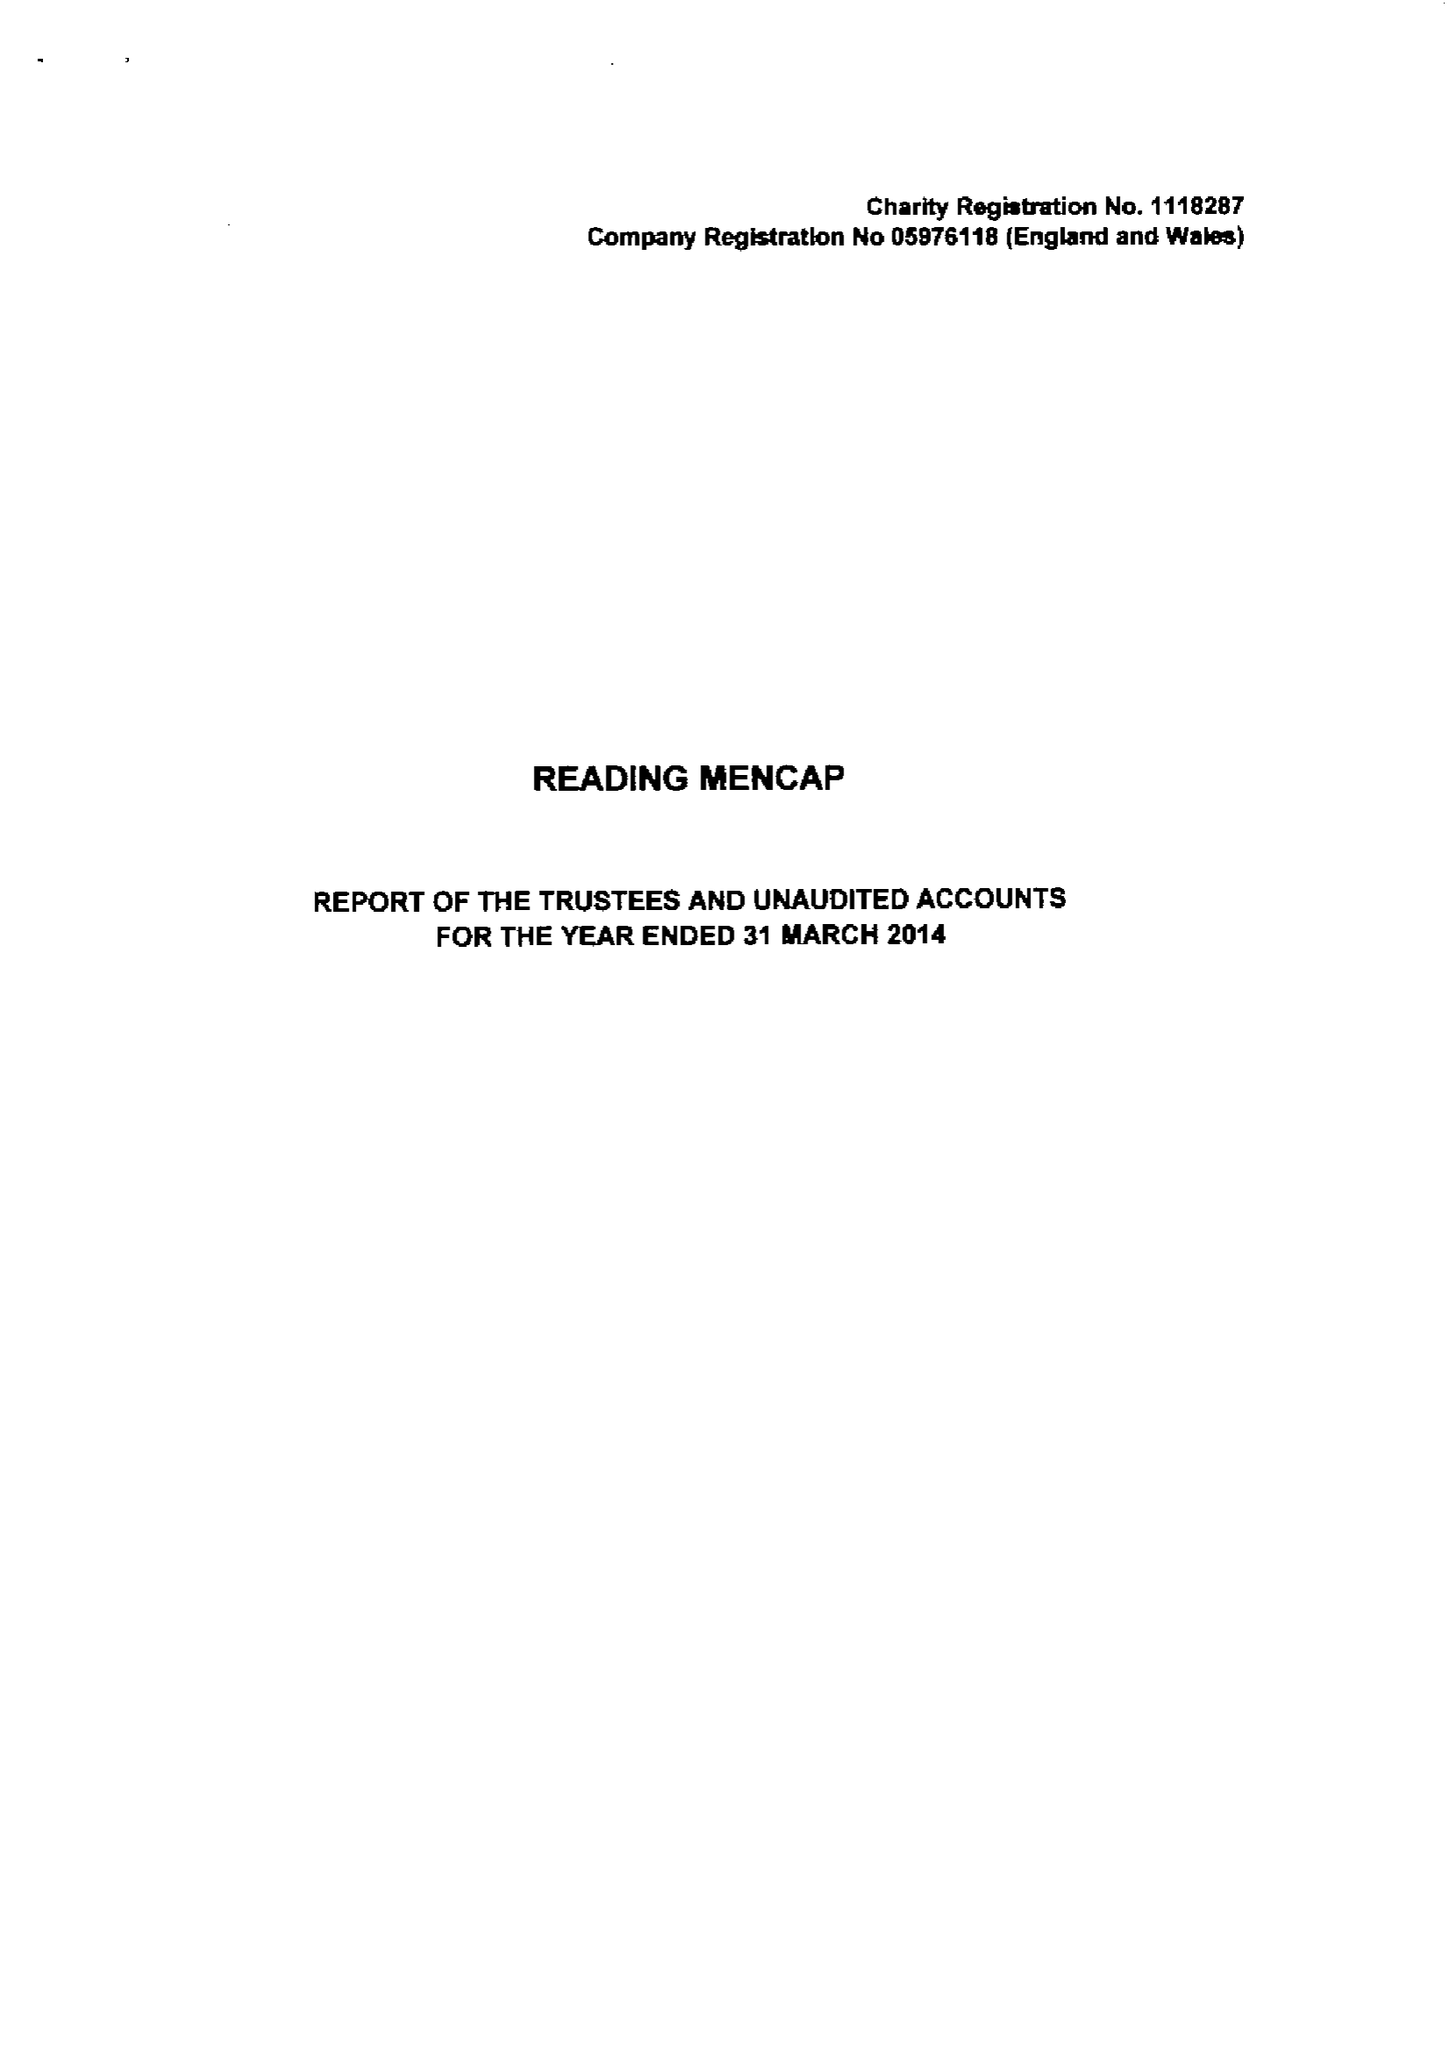What is the value for the address__post_town?
Answer the question using a single word or phrase. READING 